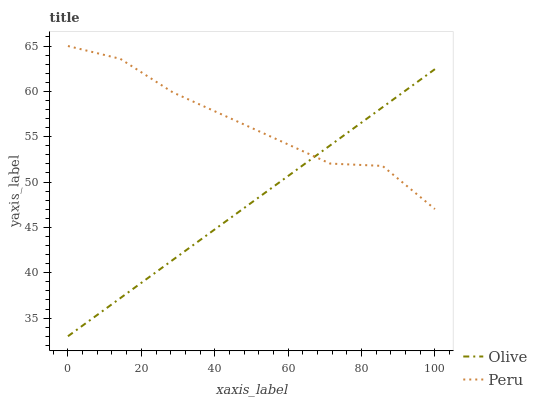Does Olive have the minimum area under the curve?
Answer yes or no. Yes. Does Peru have the maximum area under the curve?
Answer yes or no. Yes. Does Peru have the minimum area under the curve?
Answer yes or no. No. Is Olive the smoothest?
Answer yes or no. Yes. Is Peru the roughest?
Answer yes or no. Yes. Is Peru the smoothest?
Answer yes or no. No. Does Olive have the lowest value?
Answer yes or no. Yes. Does Peru have the lowest value?
Answer yes or no. No. Does Peru have the highest value?
Answer yes or no. Yes. Does Olive intersect Peru?
Answer yes or no. Yes. Is Olive less than Peru?
Answer yes or no. No. Is Olive greater than Peru?
Answer yes or no. No. 